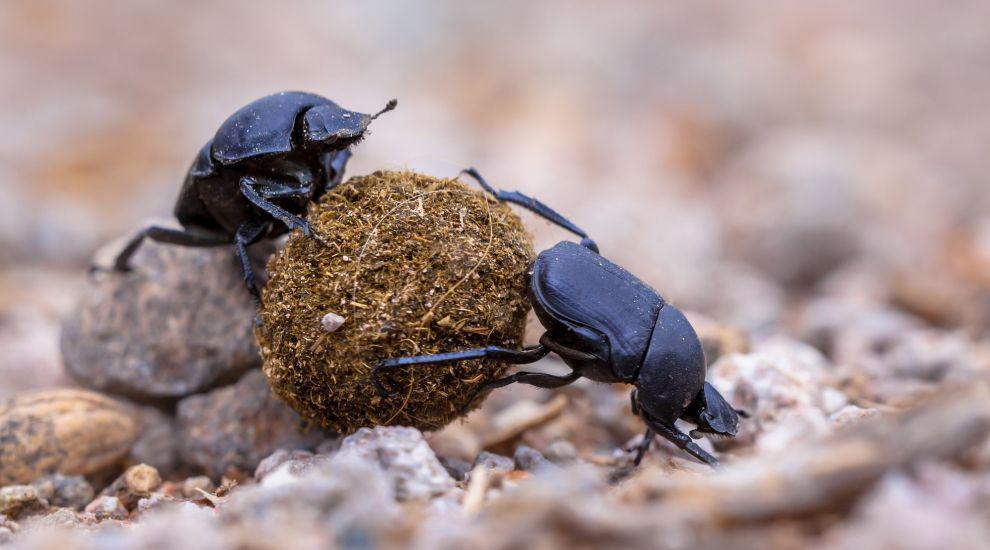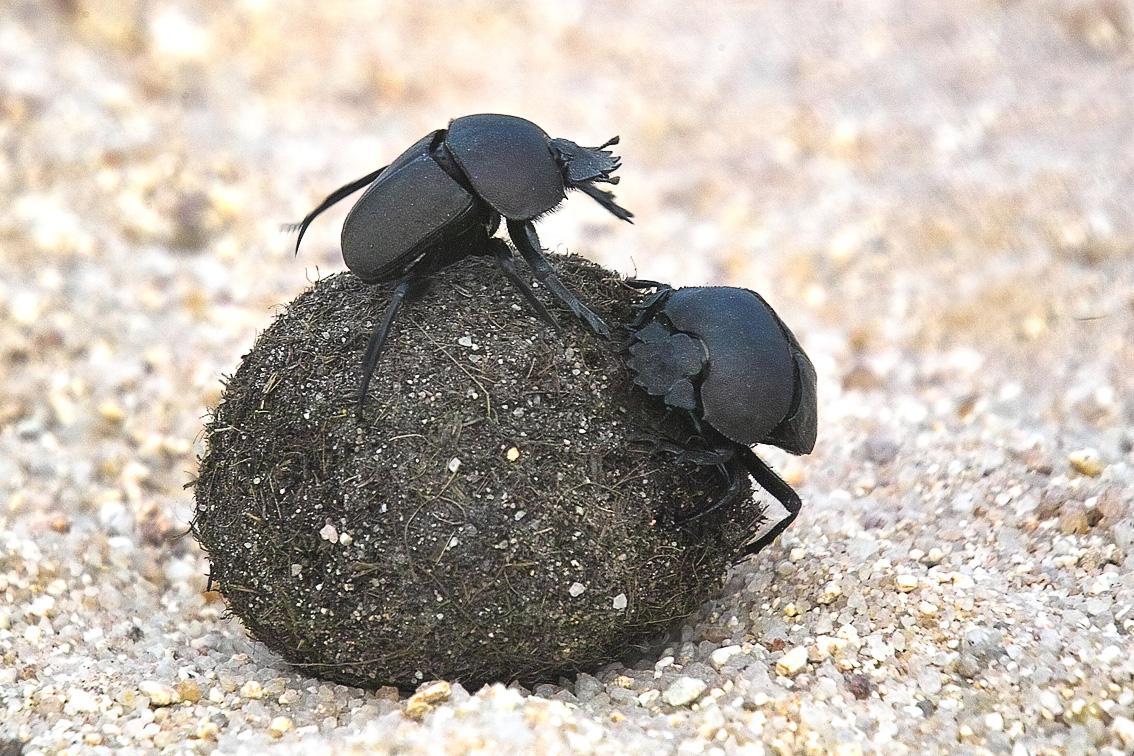The first image is the image on the left, the second image is the image on the right. Considering the images on both sides, is "There are exactly three dung beetles." valid? Answer yes or no. No. The first image is the image on the left, the second image is the image on the right. For the images shown, is this caption "there is one beetle with dung in the left side image" true? Answer yes or no. No. 